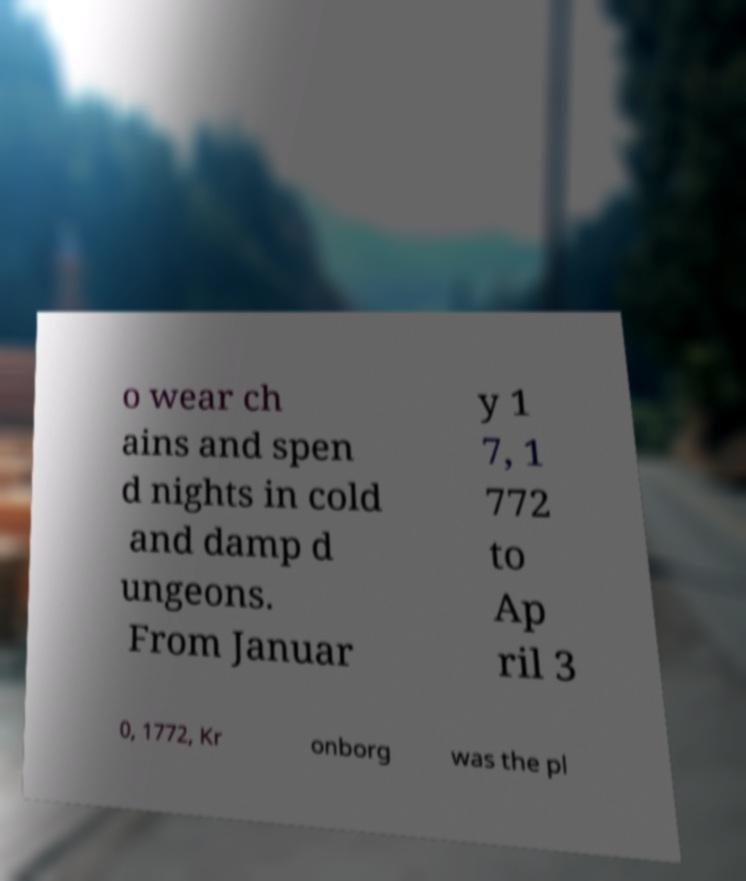There's text embedded in this image that I need extracted. Can you transcribe it verbatim? o wear ch ains and spen d nights in cold and damp d ungeons. From Januar y 1 7, 1 772 to Ap ril 3 0, 1772, Kr onborg was the pl 